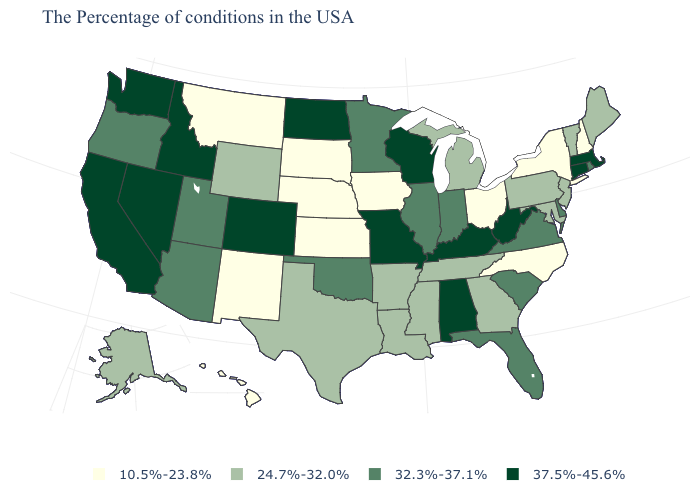What is the value of Ohio?
Answer briefly. 10.5%-23.8%. What is the value of Kentucky?
Give a very brief answer. 37.5%-45.6%. Does Louisiana have a higher value than Alaska?
Keep it brief. No. Is the legend a continuous bar?
Answer briefly. No. Does Utah have the highest value in the West?
Keep it brief. No. Does Oklahoma have the highest value in the USA?
Quick response, please. No. What is the highest value in the USA?
Be succinct. 37.5%-45.6%. How many symbols are there in the legend?
Give a very brief answer. 4. What is the highest value in states that border New Jersey?
Answer briefly. 32.3%-37.1%. What is the value of New Mexico?
Answer briefly. 10.5%-23.8%. How many symbols are there in the legend?
Write a very short answer. 4. Among the states that border Wyoming , does Idaho have the highest value?
Answer briefly. Yes. What is the value of Nebraska?
Keep it brief. 10.5%-23.8%. What is the value of Arkansas?
Answer briefly. 24.7%-32.0%. Does North Dakota have the same value as Colorado?
Short answer required. Yes. 